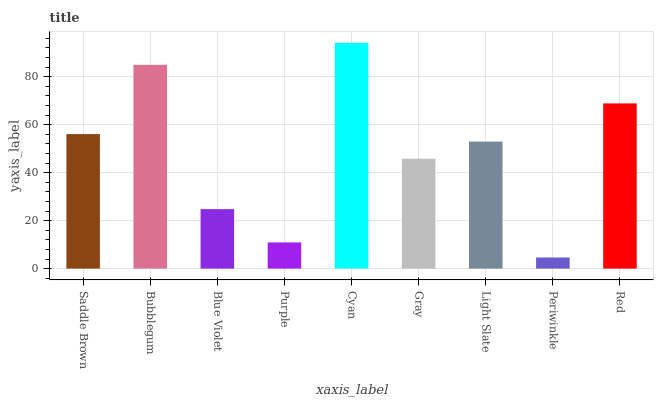Is Periwinkle the minimum?
Answer yes or no. Yes. Is Cyan the maximum?
Answer yes or no. Yes. Is Bubblegum the minimum?
Answer yes or no. No. Is Bubblegum the maximum?
Answer yes or no. No. Is Bubblegum greater than Saddle Brown?
Answer yes or no. Yes. Is Saddle Brown less than Bubblegum?
Answer yes or no. Yes. Is Saddle Brown greater than Bubblegum?
Answer yes or no. No. Is Bubblegum less than Saddle Brown?
Answer yes or no. No. Is Light Slate the high median?
Answer yes or no. Yes. Is Light Slate the low median?
Answer yes or no. Yes. Is Blue Violet the high median?
Answer yes or no. No. Is Purple the low median?
Answer yes or no. No. 